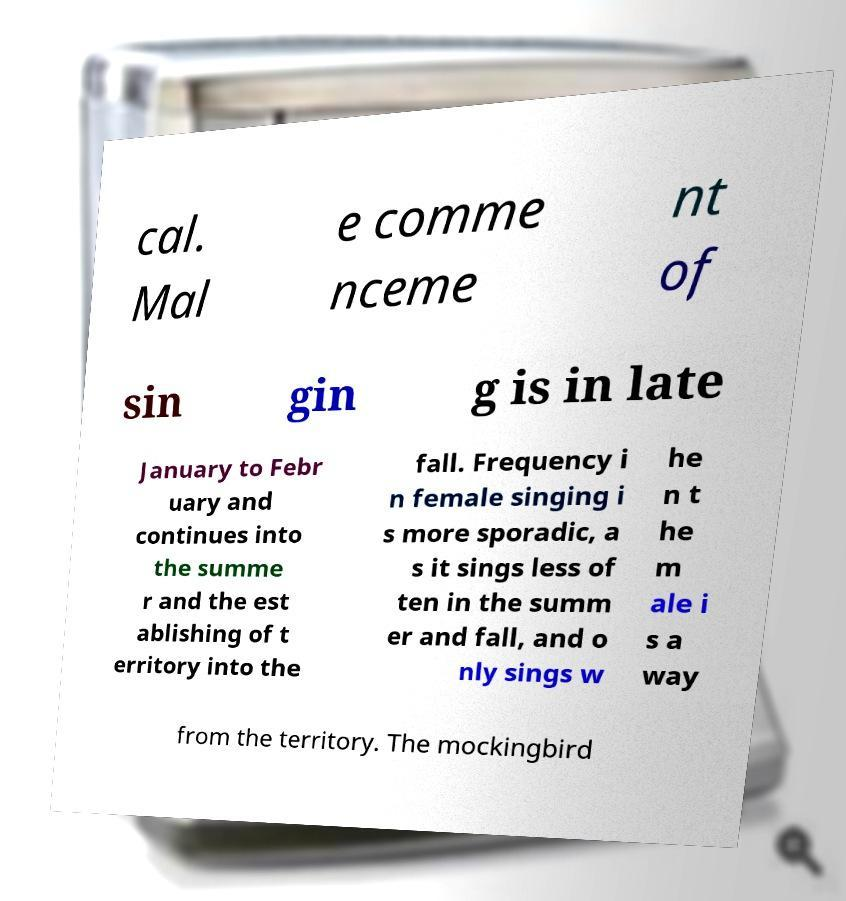Could you assist in decoding the text presented in this image and type it out clearly? cal. Mal e comme nceme nt of sin gin g is in late January to Febr uary and continues into the summe r and the est ablishing of t erritory into the fall. Frequency i n female singing i s more sporadic, a s it sings less of ten in the summ er and fall, and o nly sings w he n t he m ale i s a way from the territory. The mockingbird 